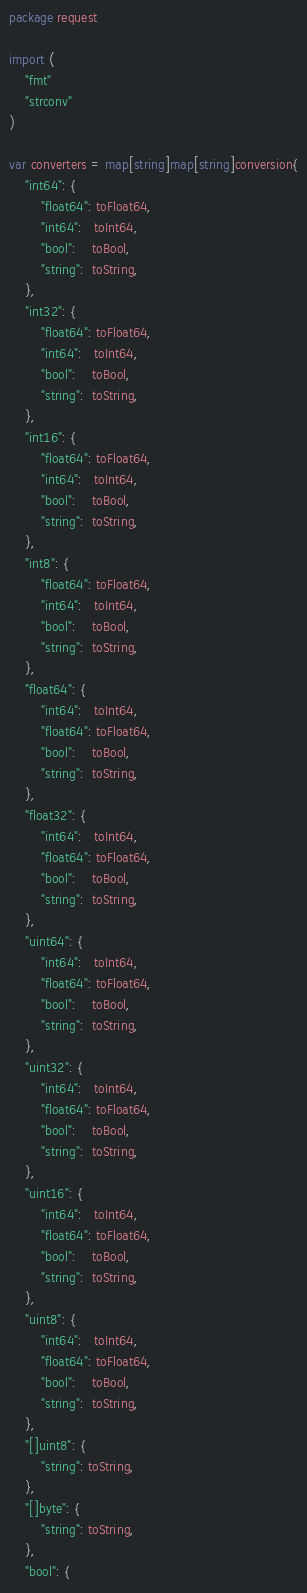<code> <loc_0><loc_0><loc_500><loc_500><_Go_>package request

import (
	"fmt"
	"strconv"
)

var converters = map[string]map[string]conversion{
	"int64": {
		"float64": toFloat64,
		"int64":   toInt64,
		"bool":    toBool,
		"string":  toString,
	},
	"int32": {
		"float64": toFloat64,
		"int64":   toInt64,
		"bool":    toBool,
		"string":  toString,
	},
	"int16": {
		"float64": toFloat64,
		"int64":   toInt64,
		"bool":    toBool,
		"string":  toString,
	},
	"int8": {
		"float64": toFloat64,
		"int64":   toInt64,
		"bool":    toBool,
		"string":  toString,
	},
	"float64": {
		"int64":   toInt64,
		"float64": toFloat64,
		"bool":    toBool,
		"string":  toString,
	},
	"float32": {
		"int64":   toInt64,
		"float64": toFloat64,
		"bool":    toBool,
		"string":  toString,
	},
	"uint64": {
		"int64":   toInt64,
		"float64": toFloat64,
		"bool":    toBool,
		"string":  toString,
	},
	"uint32": {
		"int64":   toInt64,
		"float64": toFloat64,
		"bool":    toBool,
		"string":  toString,
	},
	"uint16": {
		"int64":   toInt64,
		"float64": toFloat64,
		"bool":    toBool,
		"string":  toString,
	},
	"uint8": {
		"int64":   toInt64,
		"float64": toFloat64,
		"bool":    toBool,
		"string":  toString,
	},
	"[]uint8": {
		"string": toString,
	},
	"[]byte": {
		"string": toString,
	},
	"bool": {</code> 